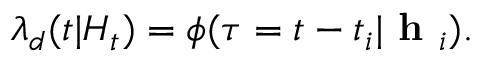<formula> <loc_0><loc_0><loc_500><loc_500>\lambda _ { d } ( t | H _ { t } ) = \phi ( \tau = t - t _ { i } | h _ { i } ) .</formula> 